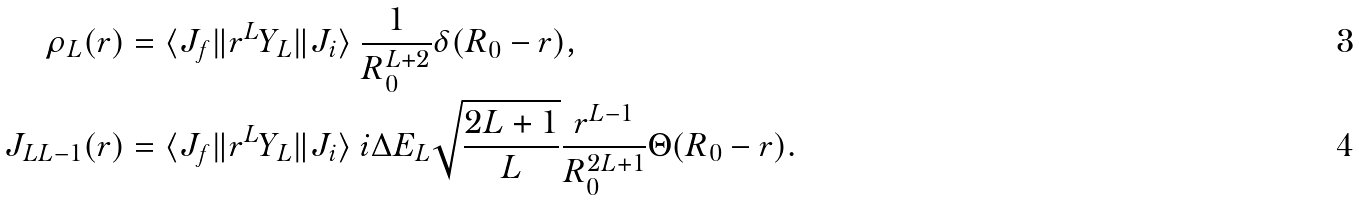<formula> <loc_0><loc_0><loc_500><loc_500>\rho _ { L } ( r ) & = \langle J _ { f } \| r ^ { L } Y _ { L } \| J _ { i } \rangle \ \frac { 1 } { R _ { 0 } ^ { L + 2 } } \delta ( R _ { 0 } - r ) , \\ J _ { L L - 1 } ( r ) & = \langle J _ { f } \| r ^ { L } Y _ { L } \| J _ { i } \rangle \ i \Delta E _ { L } \sqrt { \frac { 2 L + 1 } { L } } \frac { r ^ { L - 1 } } { R _ { 0 } ^ { 2 L + 1 } } \Theta ( R _ { 0 } - r ) .</formula> 